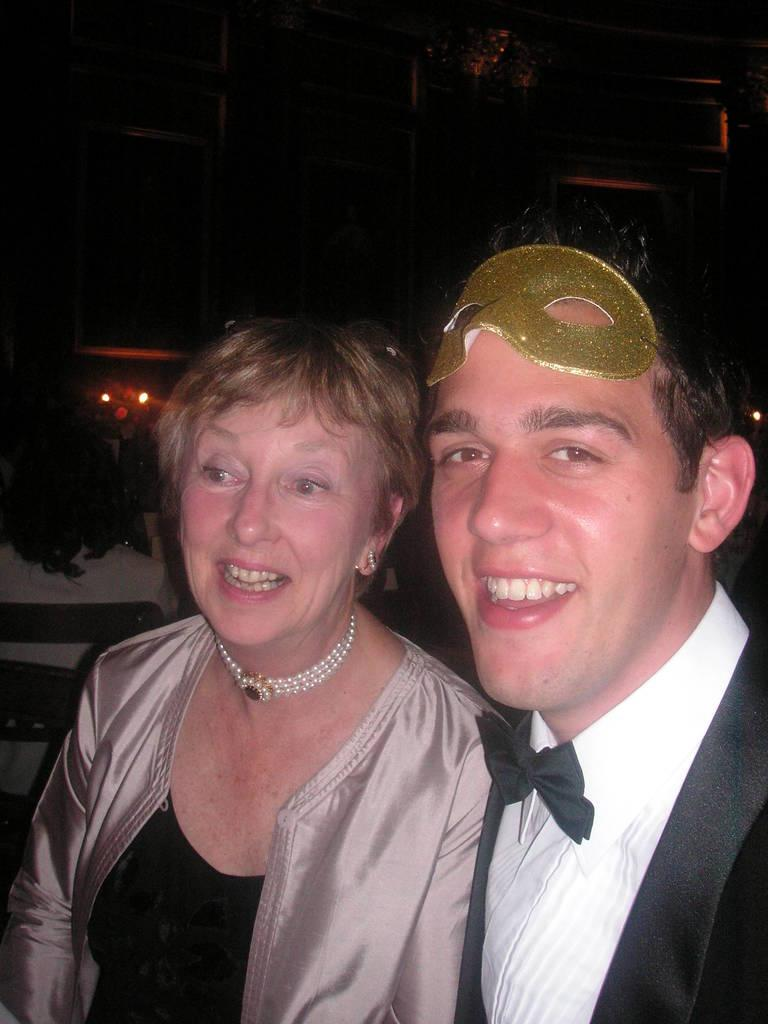Who is present in the image? There is a man and a woman in the image. What are the facial expressions of the people in the image? The man and the woman are both smiling. What can be seen in the background of the image? There are lights visible in the background of the image. Can you describe the background of the image? The background is not clear, but lights can be seen. What type of writing can be seen on the man's foot in the image? There is no writing on the man's foot in the image, and the man's foot is not visible. What kind of paste is being used by the woman in the image? There is no paste present in the image, and the woman is not using any paste. 